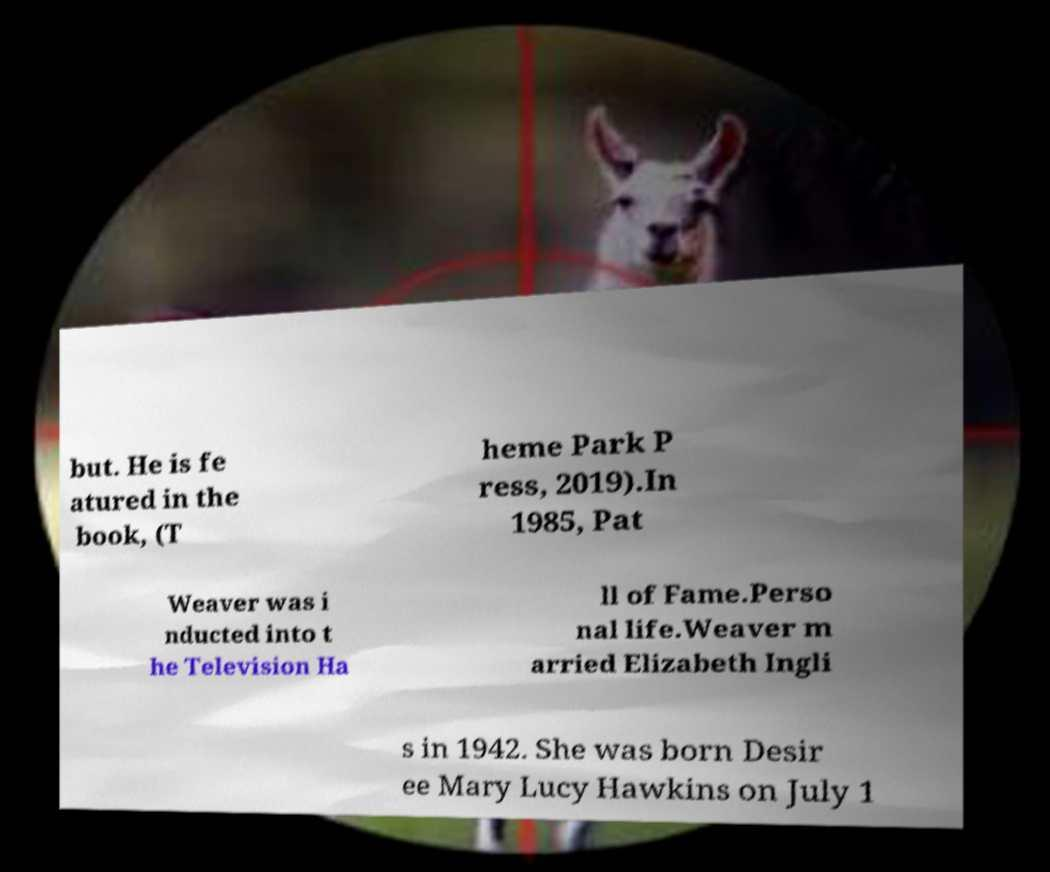Can you read and provide the text displayed in the image?This photo seems to have some interesting text. Can you extract and type it out for me? but. He is fe atured in the book, (T heme Park P ress, 2019).In 1985, Pat Weaver was i nducted into t he Television Ha ll of Fame.Perso nal life.Weaver m arried Elizabeth Ingli s in 1942. She was born Desir ee Mary Lucy Hawkins on July 1 